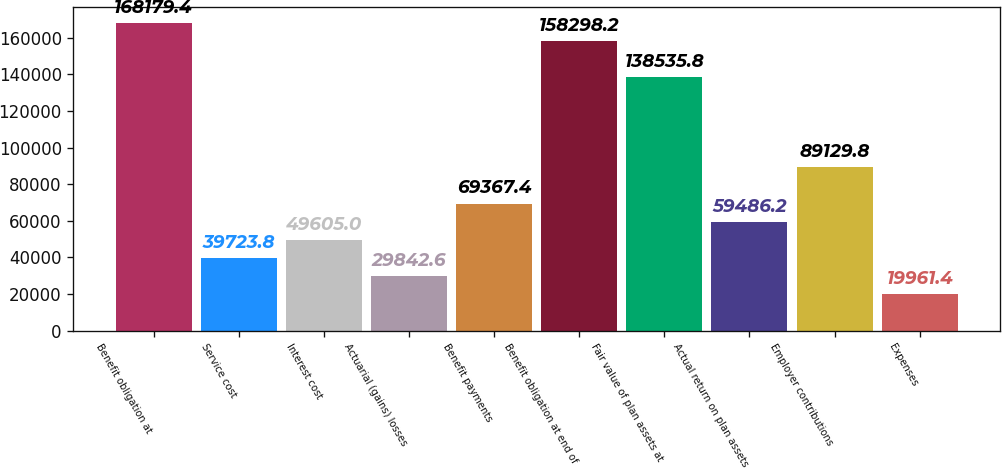Convert chart. <chart><loc_0><loc_0><loc_500><loc_500><bar_chart><fcel>Benefit obligation at<fcel>Service cost<fcel>Interest cost<fcel>Actuarial (gains) losses<fcel>Benefit payments<fcel>Benefit obligation at end of<fcel>Fair value of plan assets at<fcel>Actual return on plan assets<fcel>Employer contributions<fcel>Expenses<nl><fcel>168179<fcel>39723.8<fcel>49605<fcel>29842.6<fcel>69367.4<fcel>158298<fcel>138536<fcel>59486.2<fcel>89129.8<fcel>19961.4<nl></chart> 